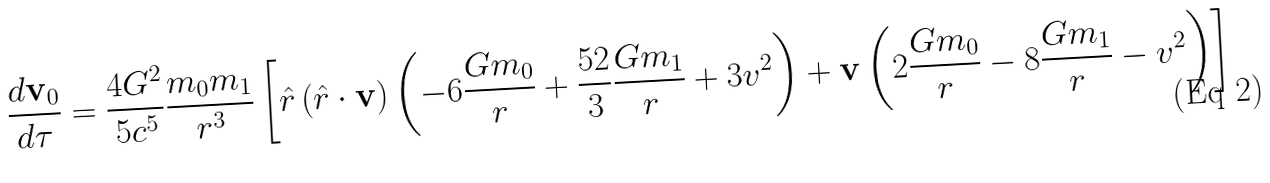<formula> <loc_0><loc_0><loc_500><loc_500>\frac { d { \mathbf v _ { 0 } } } { d \tau } = \frac { 4 G ^ { 2 } } { 5 c ^ { 5 } } \frac { m _ { 0 } m _ { 1 } } { r ^ { 3 } } \left [ { \hat { r } } \left ( { \hat { r } } \cdot { \mathbf v } \right ) \left ( - 6 \frac { G m _ { 0 } } { r } + \frac { 5 2 } { 3 } \frac { G m _ { 1 } } { r } + 3 v ^ { 2 } \right ) + { \mathbf v } \left ( 2 \frac { G m _ { 0 } } { r } - 8 \frac { G m _ { 1 } } { r } - v ^ { 2 } \right ) \right ]</formula> 